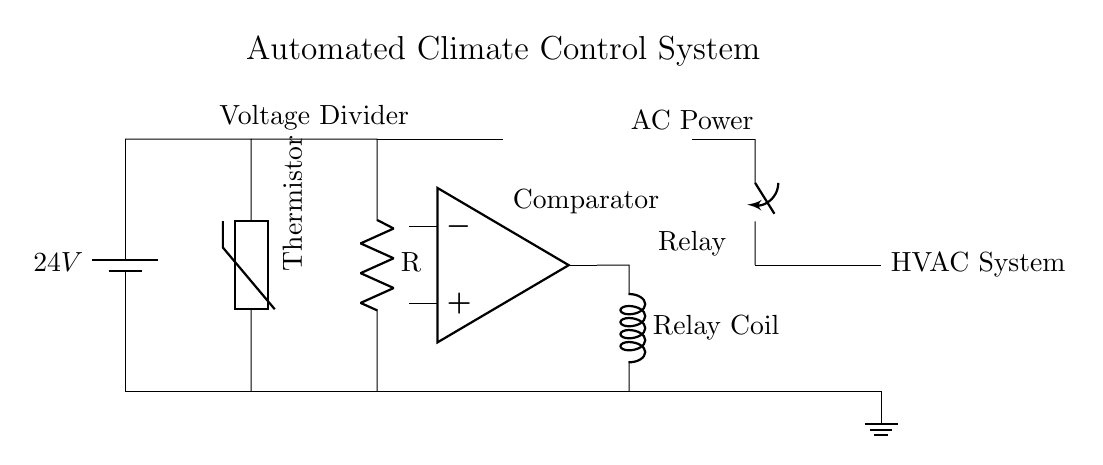What type of component is used for temperature measurement? The circuit includes a thermistor, which is a sensor that changes resistance with temperature. It is positioned between the power supply and resistor to form a voltage divider.
Answer: Thermistor What is the voltage of the power supply in the circuit? The power supply is represented as a battery in the circuit with a label indicating it provides 24 volts.
Answer: 24 volts How does the relay operate in this circuit? The relay is activated by the output of the comparator which processes the input from the thermistor to determine if the HVAC system should be turned on or off. When the relay coil receives sufficient signal, it closes the switch to power the HVAC system.
Answer: It opens and closes the HVAC circuit What is the role of the comparator in this circuit? The comparator compares the voltage from the thermistor voltage divider with a reference voltage to determine if the HVAC system needs to be activated. If the thermistor voltage indicates a temperature above or below the set point, it sends a signal to the relay.
Answer: To compare voltage levels What is the AC power connection used for in this diagram? The AC power connection indicates the source of electricity for the HVAC system, which is controlled by the relay in response to the output from the comparator. This provides the necessary power to cool or heat the unit.
Answer: To power the HVAC system Which component acts as a signal trigger for the HVAC system? The relay, upon receiving a signal from the comparator, acts as the switch that triggers the HVAC system to turn on or off based on the temperature to maintain the set climate control.
Answer: Relay 